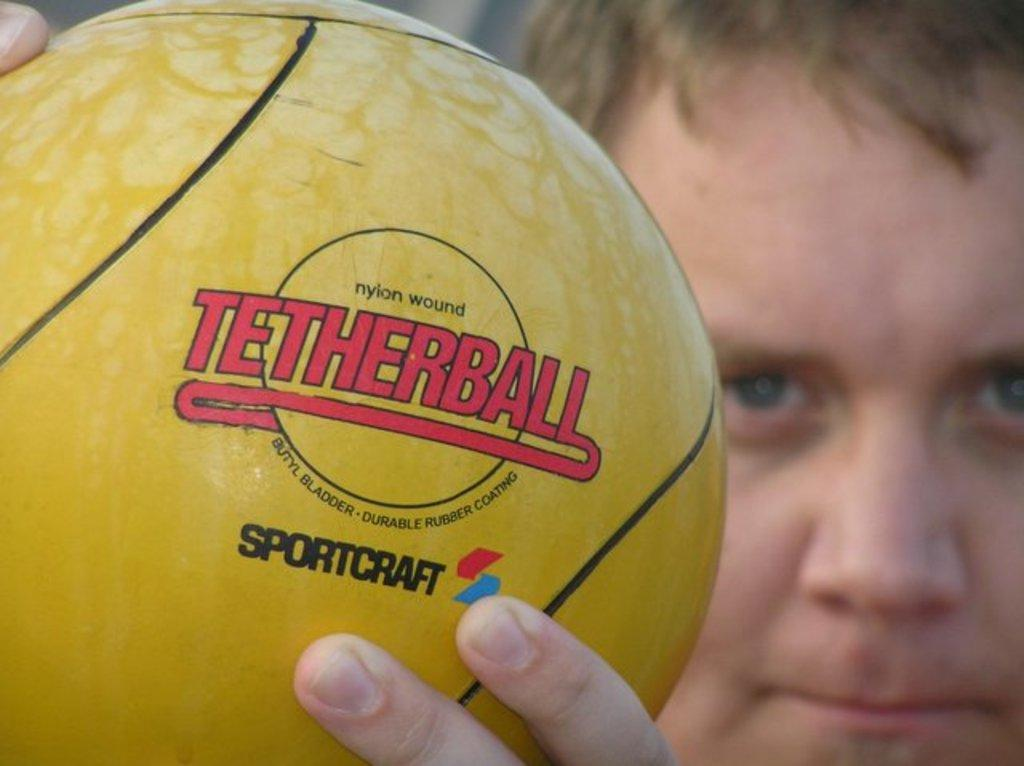What is present in the image? There is a person in the image. What is the person holding? The person is holding a ball. What type of payment is being made in the image? There is no payment being made in the image; it only features a person holding a ball. How can you tell if the person in the image is quiet? The image does not provide any information about the person's level of noise or quietness. 